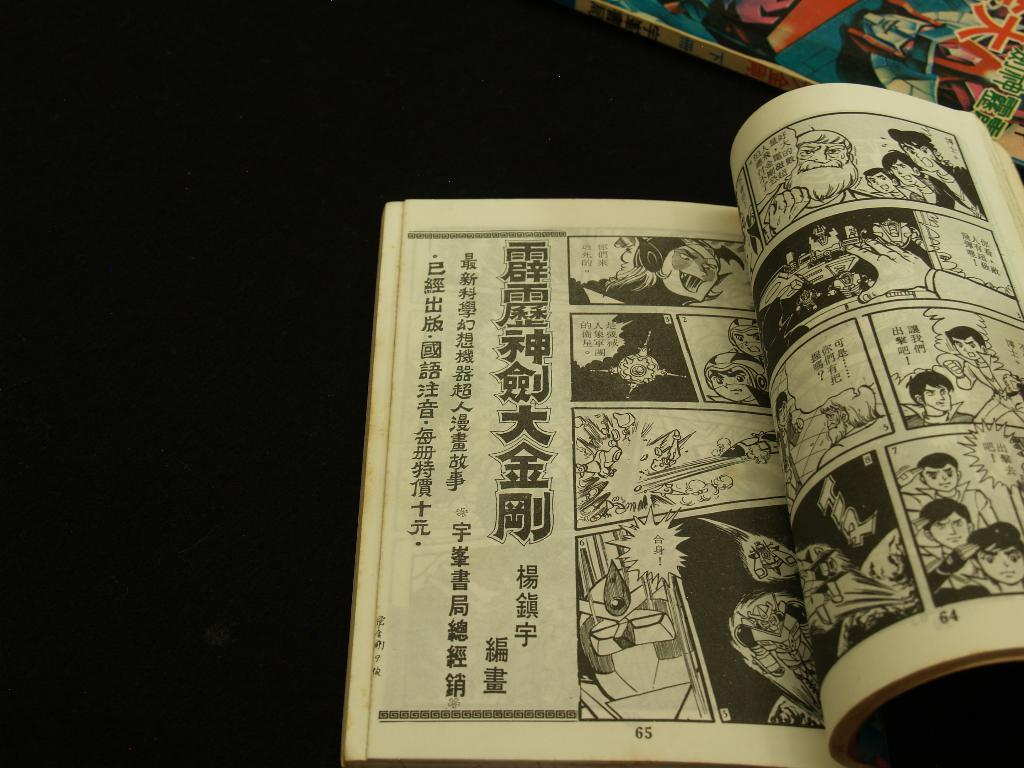<image>
Summarize the visual content of the image. A foreign comic book is open to page 65. 